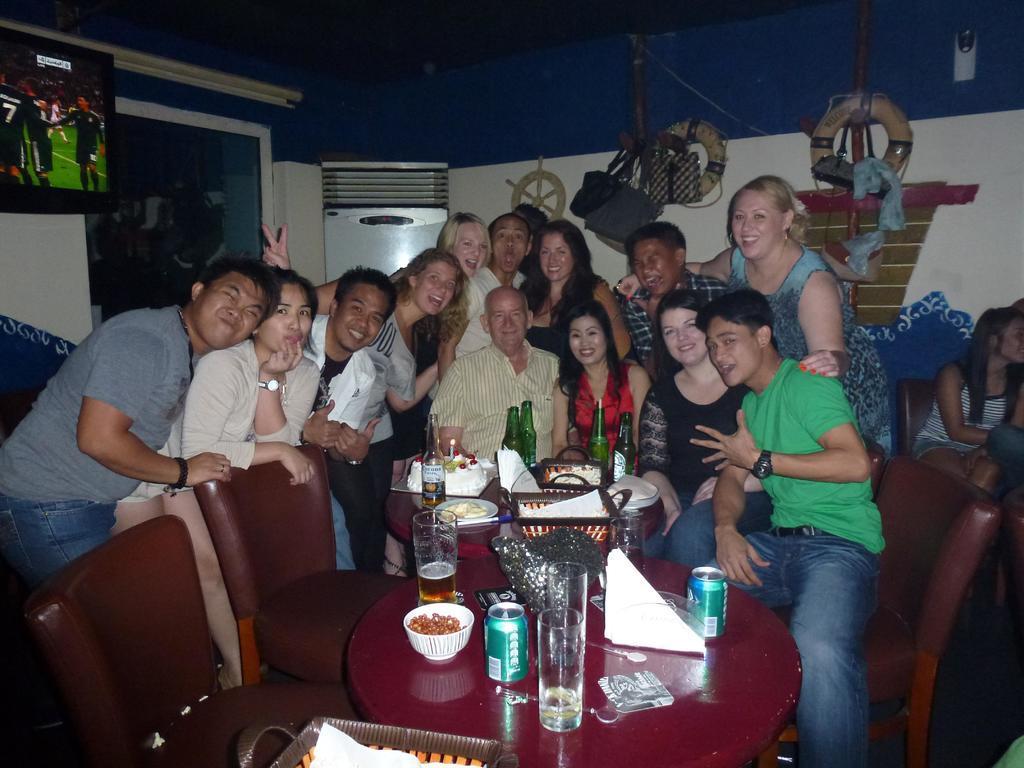Please provide a concise description of this image. In this image there are group of persons sitting and posing for a photograph in front of them there are some bottles,food items and a cake. 